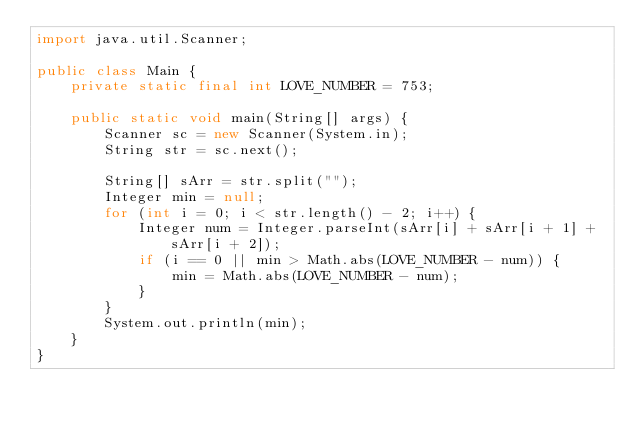Convert code to text. <code><loc_0><loc_0><loc_500><loc_500><_Java_>import java.util.Scanner;

public class Main {
    private static final int LOVE_NUMBER = 753;

    public static void main(String[] args) {
        Scanner sc = new Scanner(System.in);
        String str = sc.next();

        String[] sArr = str.split("");
        Integer min = null;
        for (int i = 0; i < str.length() - 2; i++) {
            Integer num = Integer.parseInt(sArr[i] + sArr[i + 1] + sArr[i + 2]);
            if (i == 0 || min > Math.abs(LOVE_NUMBER - num)) {
                min = Math.abs(LOVE_NUMBER - num);
            }
        }
        System.out.println(min);
    }
}
</code> 